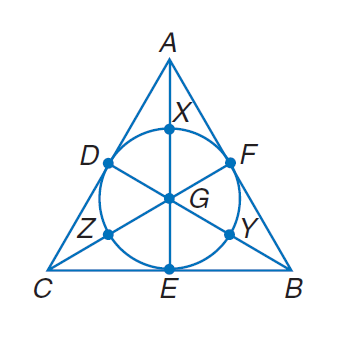Question: Find the perimeter of the polygon for the given information. B Y = C Z = A X = 2.5 diameter of \odot G = 5.
Choices:
A. 15
B. 20
C. 15 \sqrt { 3 }
D. 30
Answer with the letter. Answer: C 